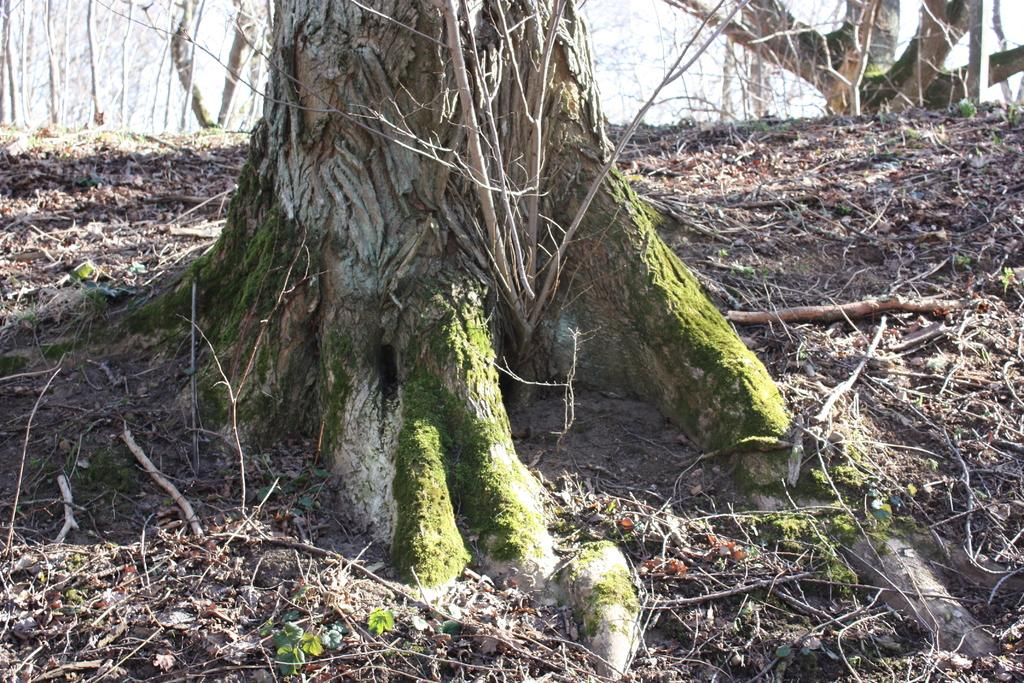What type of surface is visible in the image? There is ground visible in the image. What can be found on the ground in the image? There are trees and sticks on the ground. What story is the mother reading to the pigs in the image? There are no people, pigs, or books present in the image, so no story is being read. 